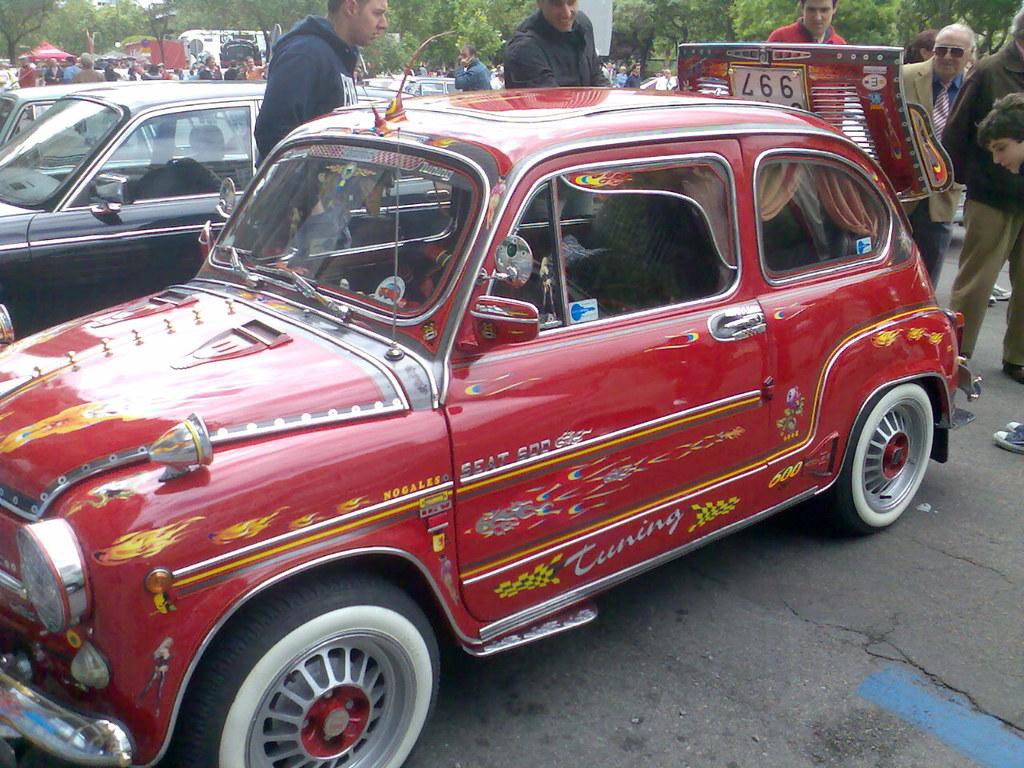What vehicle number is the red car?
Provide a short and direct response. 997. What word is written on the car?
Your answer should be very brief. Tuning. 